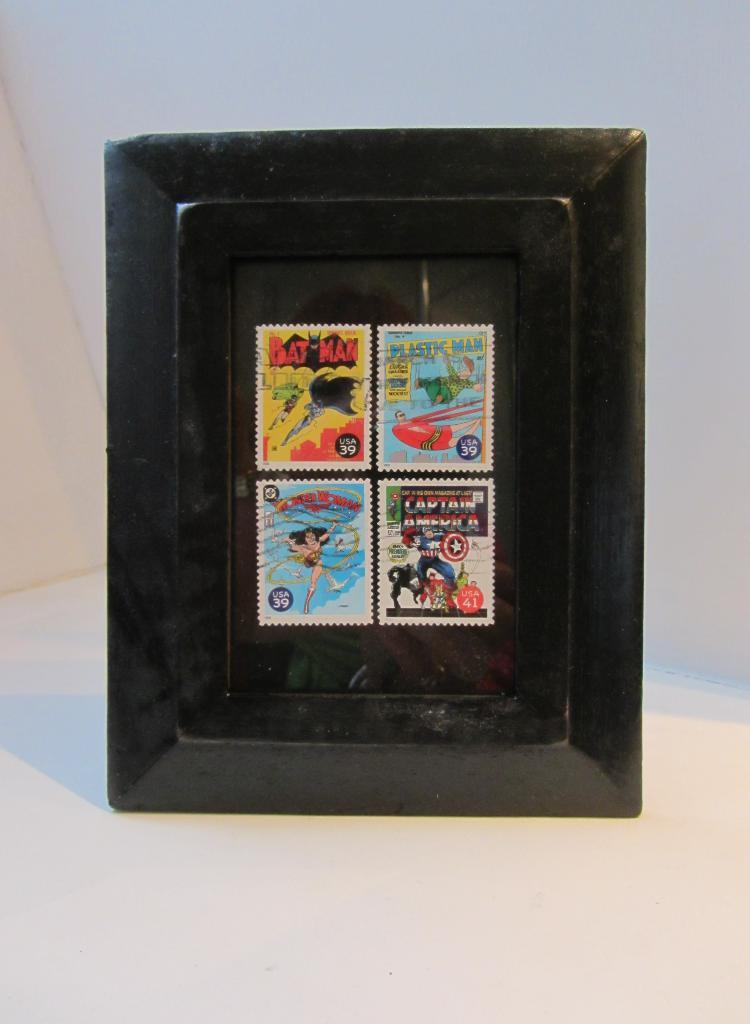<image>
Share a concise interpretation of the image provided. A framed collection of four superhero stamps such as wonder woman 